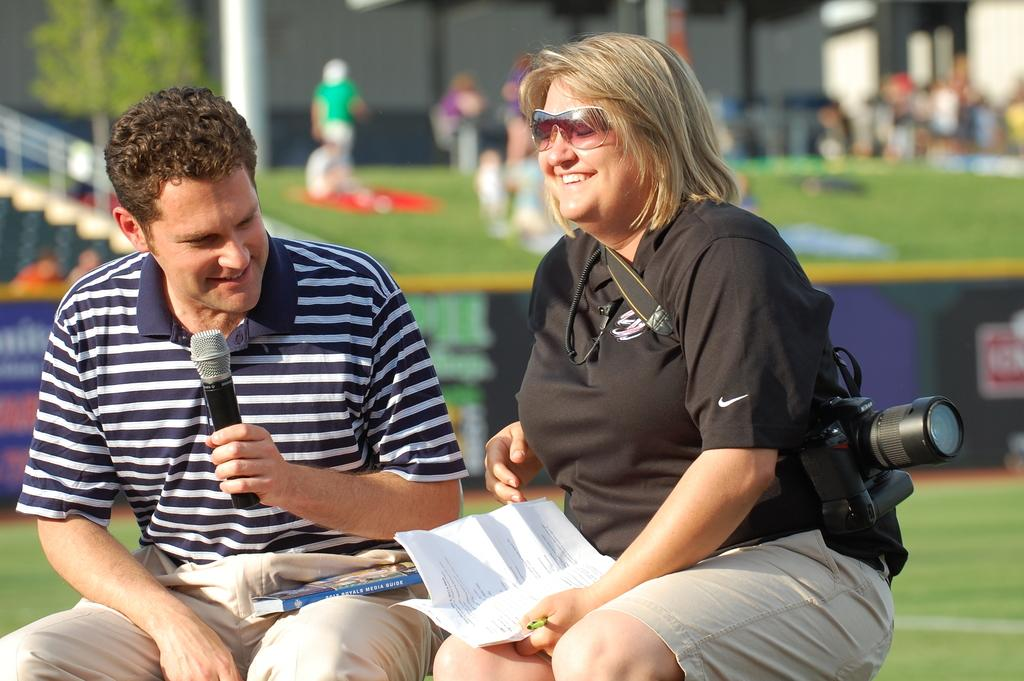How many people are sitting in the image? There are two persons sitting in the image. What object can be seen in the image that is commonly used for capturing photos? A camera is visible in the image. What type of natural environment is visible in the background of the image? There is grass in the background of the image. Can you describe the presence of other people in the image? There are people in the background of the image. What type of poison is being used to smash the camera in the image? There is no poison or smashing of the camera present in the image. 